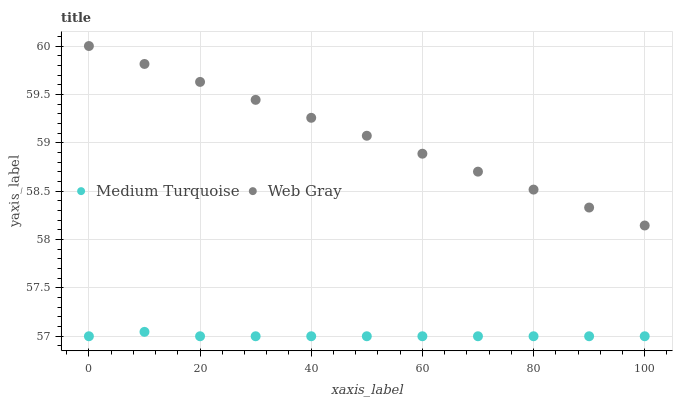Does Medium Turquoise have the minimum area under the curve?
Answer yes or no. Yes. Does Web Gray have the maximum area under the curve?
Answer yes or no. Yes. Does Medium Turquoise have the maximum area under the curve?
Answer yes or no. No. Is Web Gray the smoothest?
Answer yes or no. Yes. Is Medium Turquoise the roughest?
Answer yes or no. Yes. Is Medium Turquoise the smoothest?
Answer yes or no. No. Does Medium Turquoise have the lowest value?
Answer yes or no. Yes. Does Web Gray have the highest value?
Answer yes or no. Yes. Does Medium Turquoise have the highest value?
Answer yes or no. No. Is Medium Turquoise less than Web Gray?
Answer yes or no. Yes. Is Web Gray greater than Medium Turquoise?
Answer yes or no. Yes. Does Medium Turquoise intersect Web Gray?
Answer yes or no. No. 